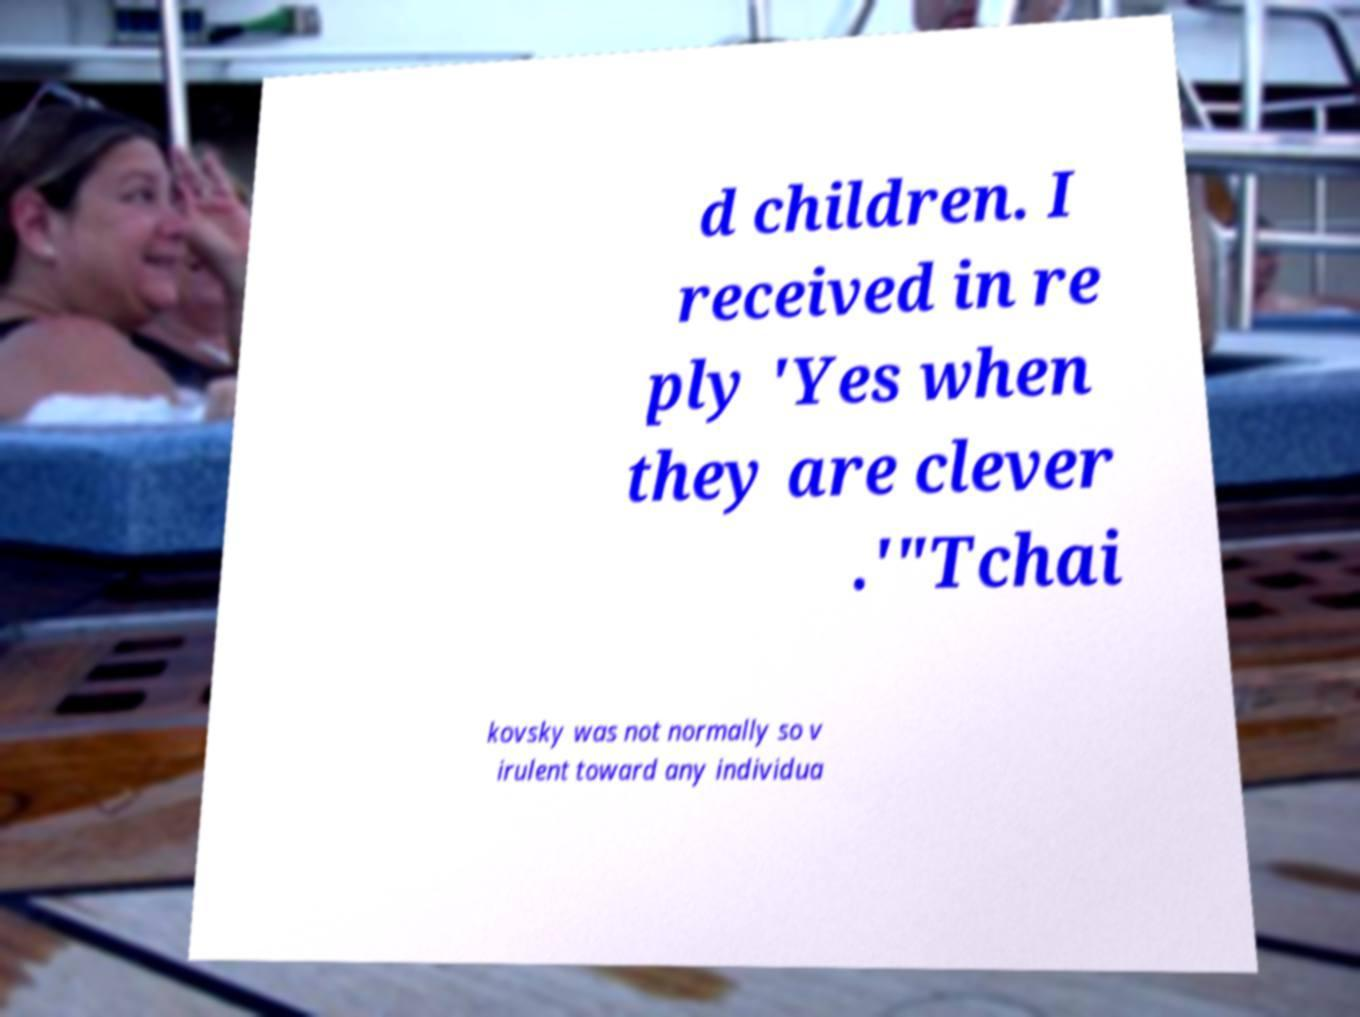There's text embedded in this image that I need extracted. Can you transcribe it verbatim? d children. I received in re ply 'Yes when they are clever .'"Tchai kovsky was not normally so v irulent toward any individua 